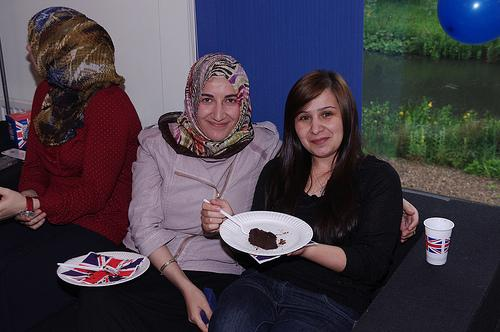Describe the scenery outside of the window. There is a waterway outside the window with yellow flowers on the brush nearby. What is unique about the cup on the table and the balloon near the window? The cup has a British flag design, and the blue balloon appears to be floating in the air. Can you elaborate on what the person wearing a blue jeans is holding? The person wearing blue jeans is holding a white plate with brown food, possibly chocolate cake, and a white plastic fork in their hand. What kind of food is being eaten and what is it being eaten with? A woman is eating a chocolate cake with a white plastic fork. In this picture, how many diverse items have designs featuring the British flag? There are 3 items with British flag designs: a paper cup, a napkin, and a plate with cake crumbs. Can you provide a specific description of the two women at the center of the image? Two women are sitting together, both wearing scarfs on their heads. One is eating chocolate cake with a plastic fork while the other is wearing a red sweater and holding a white plate. What are the women doing in this image and what are some of their clothing accessories? The women are sitting together on a sofa, wearing scarfs on their heads and a mix of outerwear such as red sweaters, gray coats, and red and black shirts. Can you describe the person with the silver bracelet? A woman wearing a gray coat, with a scarf around her head, and a silver bracelet on her wrist. How many people in the image are wearing watches, and what colors are the watches? Two women are wearing watches - one with a red watch and the other with a silver bracelet watch. How many paper items can be found on the table and what are their designs? There are 2 paper items on the table: a cup with a British flag design and a napkin with a British flag design. 